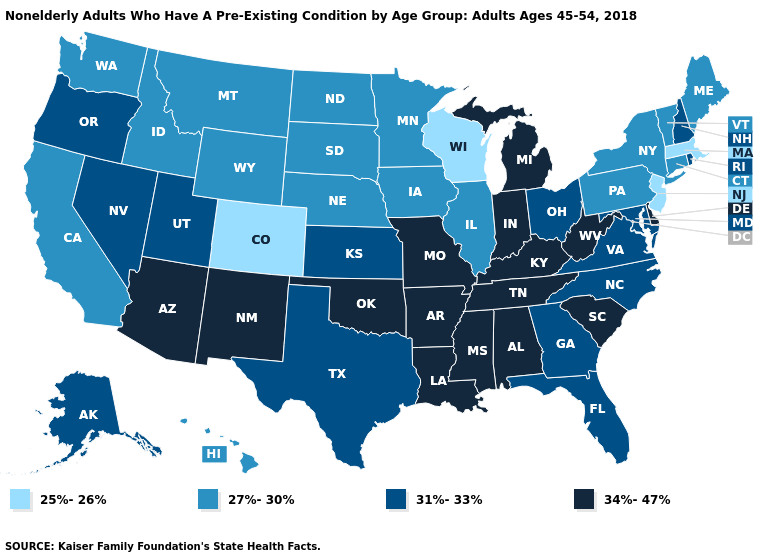Which states have the lowest value in the MidWest?
Short answer required. Wisconsin. What is the value of Ohio?
Short answer required. 31%-33%. Among the states that border Iowa , does South Dakota have the highest value?
Short answer required. No. Does Indiana have the highest value in the USA?
Be succinct. Yes. What is the value of Nebraska?
Write a very short answer. 27%-30%. What is the highest value in states that border Mississippi?
Short answer required. 34%-47%. Among the states that border Kansas , which have the lowest value?
Concise answer only. Colorado. Name the states that have a value in the range 25%-26%?
Answer briefly. Colorado, Massachusetts, New Jersey, Wisconsin. How many symbols are there in the legend?
Answer briefly. 4. Name the states that have a value in the range 34%-47%?
Answer briefly. Alabama, Arizona, Arkansas, Delaware, Indiana, Kentucky, Louisiana, Michigan, Mississippi, Missouri, New Mexico, Oklahoma, South Carolina, Tennessee, West Virginia. Name the states that have a value in the range 27%-30%?
Write a very short answer. California, Connecticut, Hawaii, Idaho, Illinois, Iowa, Maine, Minnesota, Montana, Nebraska, New York, North Dakota, Pennsylvania, South Dakota, Vermont, Washington, Wyoming. What is the value of North Carolina?
Quick response, please. 31%-33%. Among the states that border Nebraska , which have the lowest value?
Keep it brief. Colorado. Among the states that border Washington , does Oregon have the lowest value?
Short answer required. No. What is the highest value in the USA?
Concise answer only. 34%-47%. 